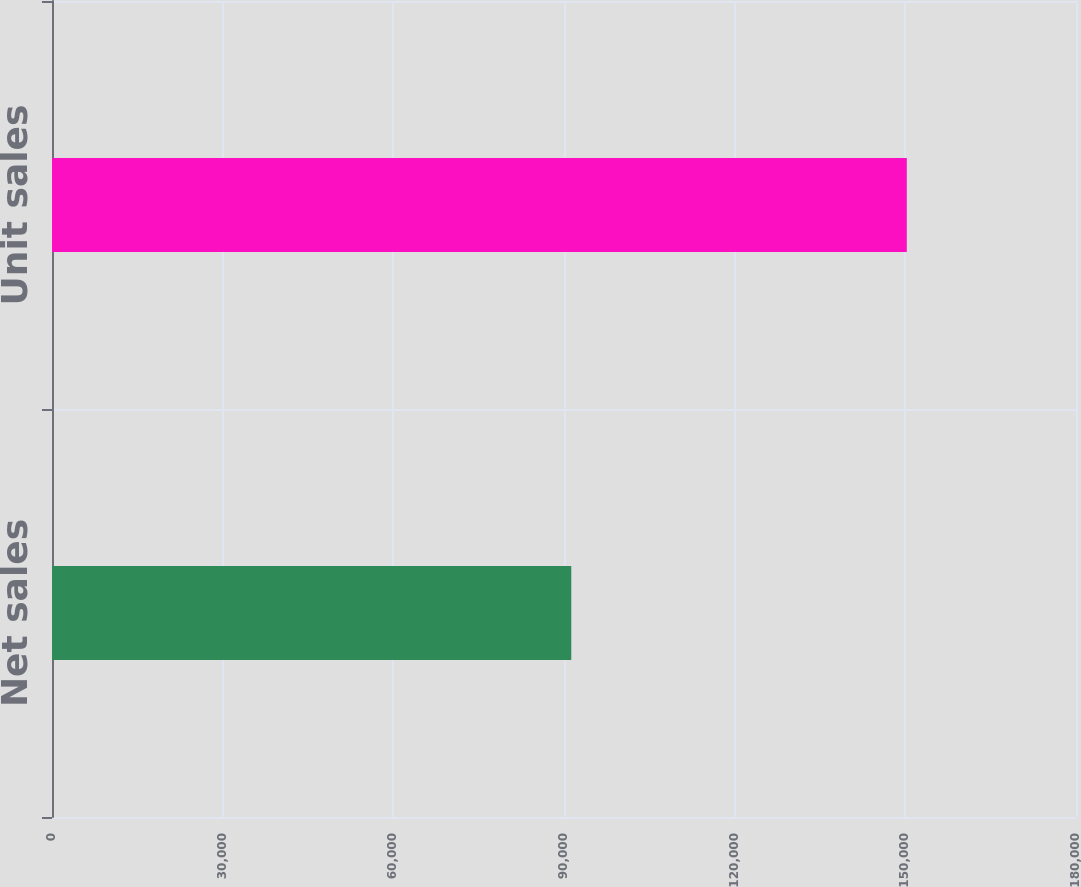Convert chart to OTSL. <chart><loc_0><loc_0><loc_500><loc_500><bar_chart><fcel>Net sales<fcel>Unit sales<nl><fcel>91279<fcel>150257<nl></chart> 